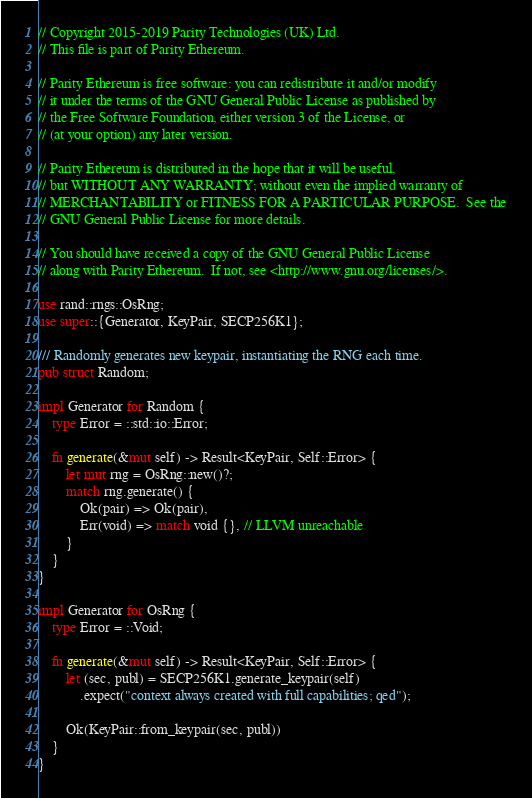Convert code to text. <code><loc_0><loc_0><loc_500><loc_500><_Rust_>// Copyright 2015-2019 Parity Technologies (UK) Ltd.
// This file is part of Parity Ethereum.

// Parity Ethereum is free software: you can redistribute it and/or modify
// it under the terms of the GNU General Public License as published by
// the Free Software Foundation, either version 3 of the License, or
// (at your option) any later version.

// Parity Ethereum is distributed in the hope that it will be useful,
// but WITHOUT ANY WARRANTY; without even the implied warranty of
// MERCHANTABILITY or FITNESS FOR A PARTICULAR PURPOSE.  See the
// GNU General Public License for more details.

// You should have received a copy of the GNU General Public License
// along with Parity Ethereum.  If not, see <http://www.gnu.org/licenses/>.

use rand::rngs::OsRng;
use super::{Generator, KeyPair, SECP256K1};

/// Randomly generates new keypair, instantiating the RNG each time.
pub struct Random;

impl Generator for Random {
	type Error = ::std::io::Error;

	fn generate(&mut self) -> Result<KeyPair, Self::Error> {
		let mut rng = OsRng::new()?;
		match rng.generate() {
			Ok(pair) => Ok(pair),
			Err(void) => match void {}, // LLVM unreachable
		}
	}
}

impl Generator for OsRng {
	type Error = ::Void;

	fn generate(&mut self) -> Result<KeyPair, Self::Error> {
		let (sec, publ) = SECP256K1.generate_keypair(self)
			.expect("context always created with full capabilities; qed");

		Ok(KeyPair::from_keypair(sec, publ))
	}
}
</code> 